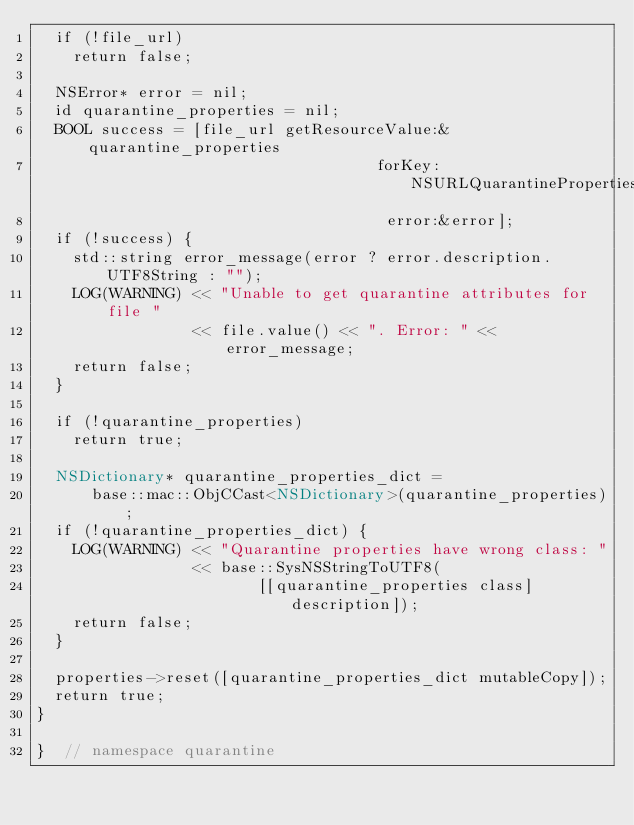<code> <loc_0><loc_0><loc_500><loc_500><_ObjectiveC_>  if (!file_url)
    return false;

  NSError* error = nil;
  id quarantine_properties = nil;
  BOOL success = [file_url getResourceValue:&quarantine_properties
                                     forKey:NSURLQuarantinePropertiesKey
                                      error:&error];
  if (!success) {
    std::string error_message(error ? error.description.UTF8String : "");
    LOG(WARNING) << "Unable to get quarantine attributes for file "
                 << file.value() << ". Error: " << error_message;
    return false;
  }

  if (!quarantine_properties)
    return true;

  NSDictionary* quarantine_properties_dict =
      base::mac::ObjCCast<NSDictionary>(quarantine_properties);
  if (!quarantine_properties_dict) {
    LOG(WARNING) << "Quarantine properties have wrong class: "
                 << base::SysNSStringToUTF8(
                        [[quarantine_properties class] description]);
    return false;
  }

  properties->reset([quarantine_properties_dict mutableCopy]);
  return true;
}

}  // namespace quarantine
</code> 